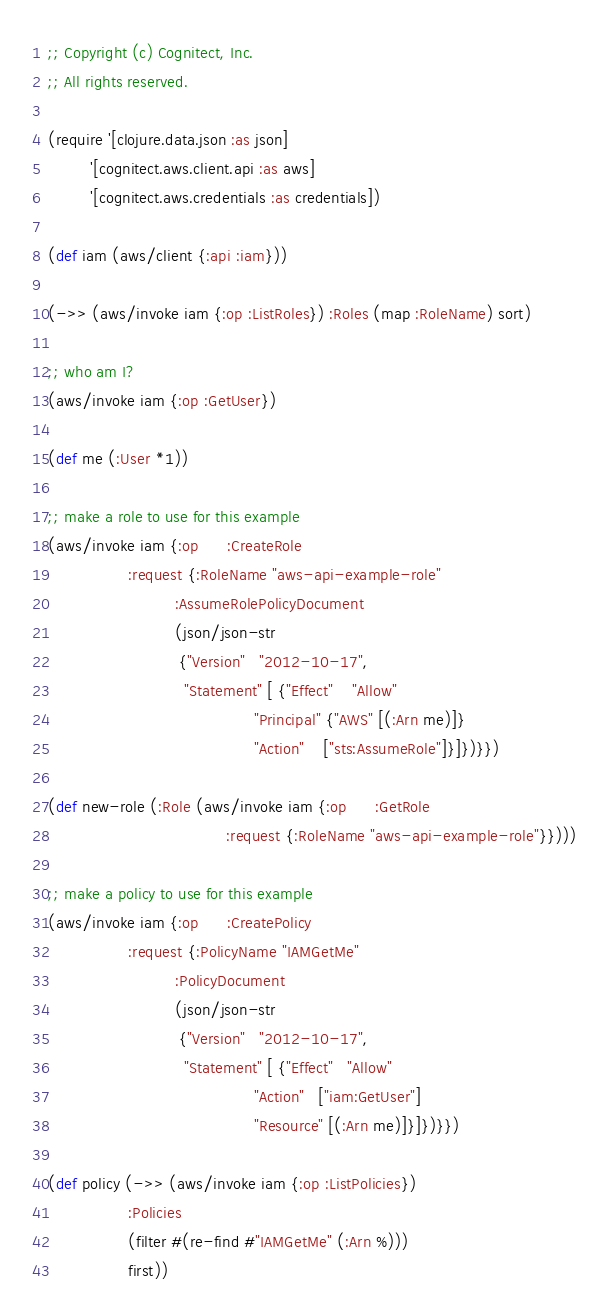<code> <loc_0><loc_0><loc_500><loc_500><_Clojure_>;; Copyright (c) Cognitect, Inc.
;; All rights reserved.

(require '[clojure.data.json :as json]
         '[cognitect.aws.client.api :as aws]
         '[cognitect.aws.credentials :as credentials])

(def iam (aws/client {:api :iam}))

(->> (aws/invoke iam {:op :ListRoles}) :Roles (map :RoleName) sort)

;; who am I?
(aws/invoke iam {:op :GetUser})

(def me (:User *1))

;; make a role to use for this example
(aws/invoke iam {:op      :CreateRole
                 :request {:RoleName "aws-api-example-role"
                           :AssumeRolePolicyDocument
                           (json/json-str
                            {"Version"   "2012-10-17",
                             "Statement" [ {"Effect"    "Allow"
                                            "Principal" {"AWS" [(:Arn me)]}
                                            "Action"    ["sts:AssumeRole"]}]})}})

(def new-role (:Role (aws/invoke iam {:op      :GetRole
                                      :request {:RoleName "aws-api-example-role"}})))

;; make a policy to use for this example
(aws/invoke iam {:op      :CreatePolicy
                 :request {:PolicyName "IAMGetMe"
                           :PolicyDocument
                           (json/json-str
                            {"Version"   "2012-10-17",
                             "Statement" [ {"Effect"   "Allow"
                                            "Action"   ["iam:GetUser"]
                                            "Resource" [(:Arn me)]}]})}})

(def policy (->> (aws/invoke iam {:op :ListPolicies})
                 :Policies
                 (filter #(re-find #"IAMGetMe" (:Arn %)))
                 first))
</code> 